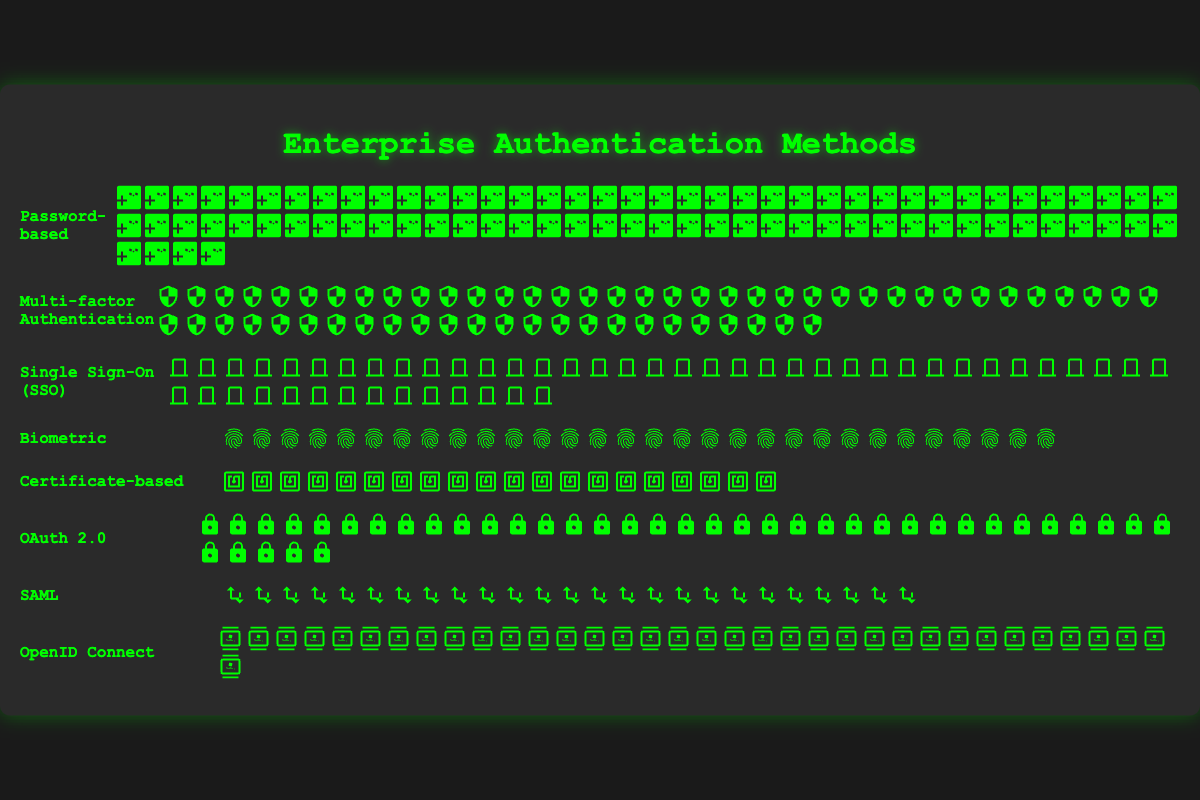Which authentication method is used the most in enterprise environments? The figure shows that "Password-based" authentication has the highest count with 80 icons.
Answer: Password-based How many more enterprises use Multi-factor Authentication than Certificate-based authentication? Multi-factor Authentication has 60 icons, while Certificate-based has 20. The difference is 60-20.
Answer: 40 What is the total number of enterprises using either Biometric or SAML authentication methods? The count for Biometric is 30 and for SAML is 25. The total is 30 + 25.
Answer: 55 Which is used more frequently: OAuth 2.0 or Single Sign-On (SSO)? By comparing the icons, OAuth 2.0 has 40 whereas SSO has 50. SSO is used more frequently.
Answer: Single Sign-On (SSO) Rank the methods in order from most used to least used. The figure shows the counts: Password-based (80), Multi-factor Authentication (60), Single Sign-On (50), OAuth 2.0 (40), OpenID Connect (35), Biometric (30), SAML (25), Certificate-based (20).
Answer: Password-based, Multi-factor Authentication, Single Sign-On, OAuth 2.0, OpenID Connect, Biometric, SAML, Certificate-based How many enterprises in total are represented in the figure? Sum the count for all methods: 80 (Password-based) + 60 (Multi-factor Authentication) + 50 (Single Sign-On) + 30 (Biometric) + 20 (Certificate-based) + 40 (OAuth 2.0) + 25 (SAML) + 35 (OpenID Connect). The total is 80 + 60 + 50 + 30 + 20 + 40 + 25 + 35.
Answer: 340 Which two authentication methods have a combined count of 110 enterprises? Checking different combinations, Multi-factor Authentication (60) + Single Sign-On (50) equals 110.
Answer: Multi-factor Authentication and Single Sign-On What percentage of the enterprises use OpenID Connect? OpenID Connect accounts for 35 out of the total 340. The percentage is (35/340) * 100.
Answer: 10.29% Is the number of enterprises using OAuth 2.0 higher than those using Biometric authentication? OAuth 2.0 has 40 icons while Biometric has 30. Therefore, OAuth 2.0 is higher.
Answer: Yes Which method has the second lowest usage? The counts show the lowest is Certificate-based (20), and the second lowest is SAML (25).
Answer: SAML 